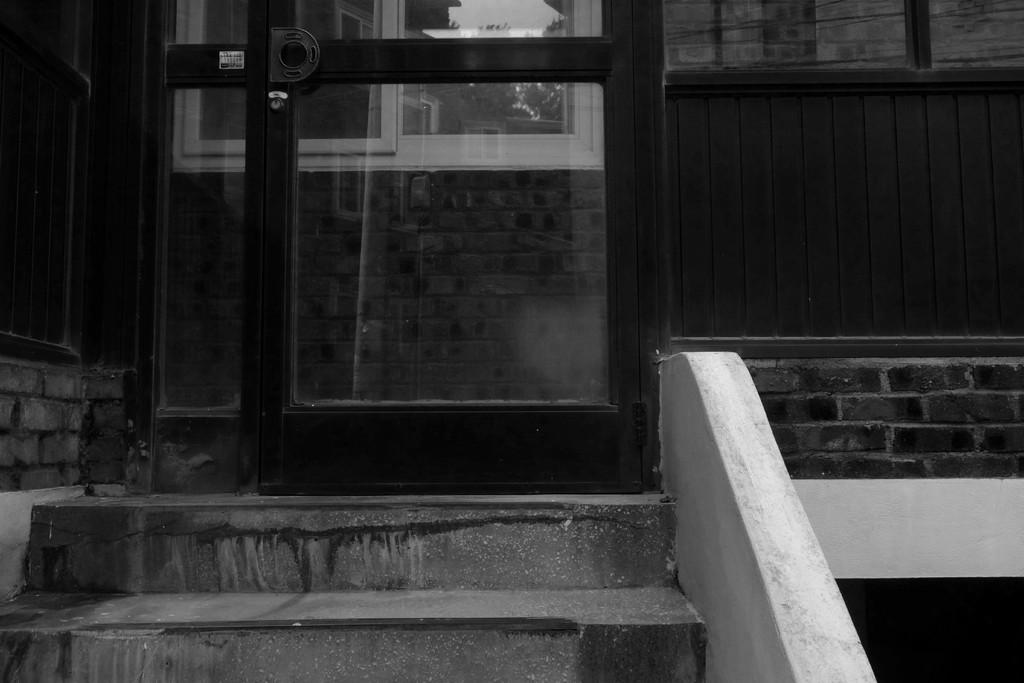What is the main subject of the black and white picture? The main subject of the black and white picture is a building. What can be seen in the foreground of the image? There is a door, a window, and a staircase in the foreground of the image. What type of trousers is the building wearing in the image? Buildings do not wear trousers, as they are inanimate objects. 